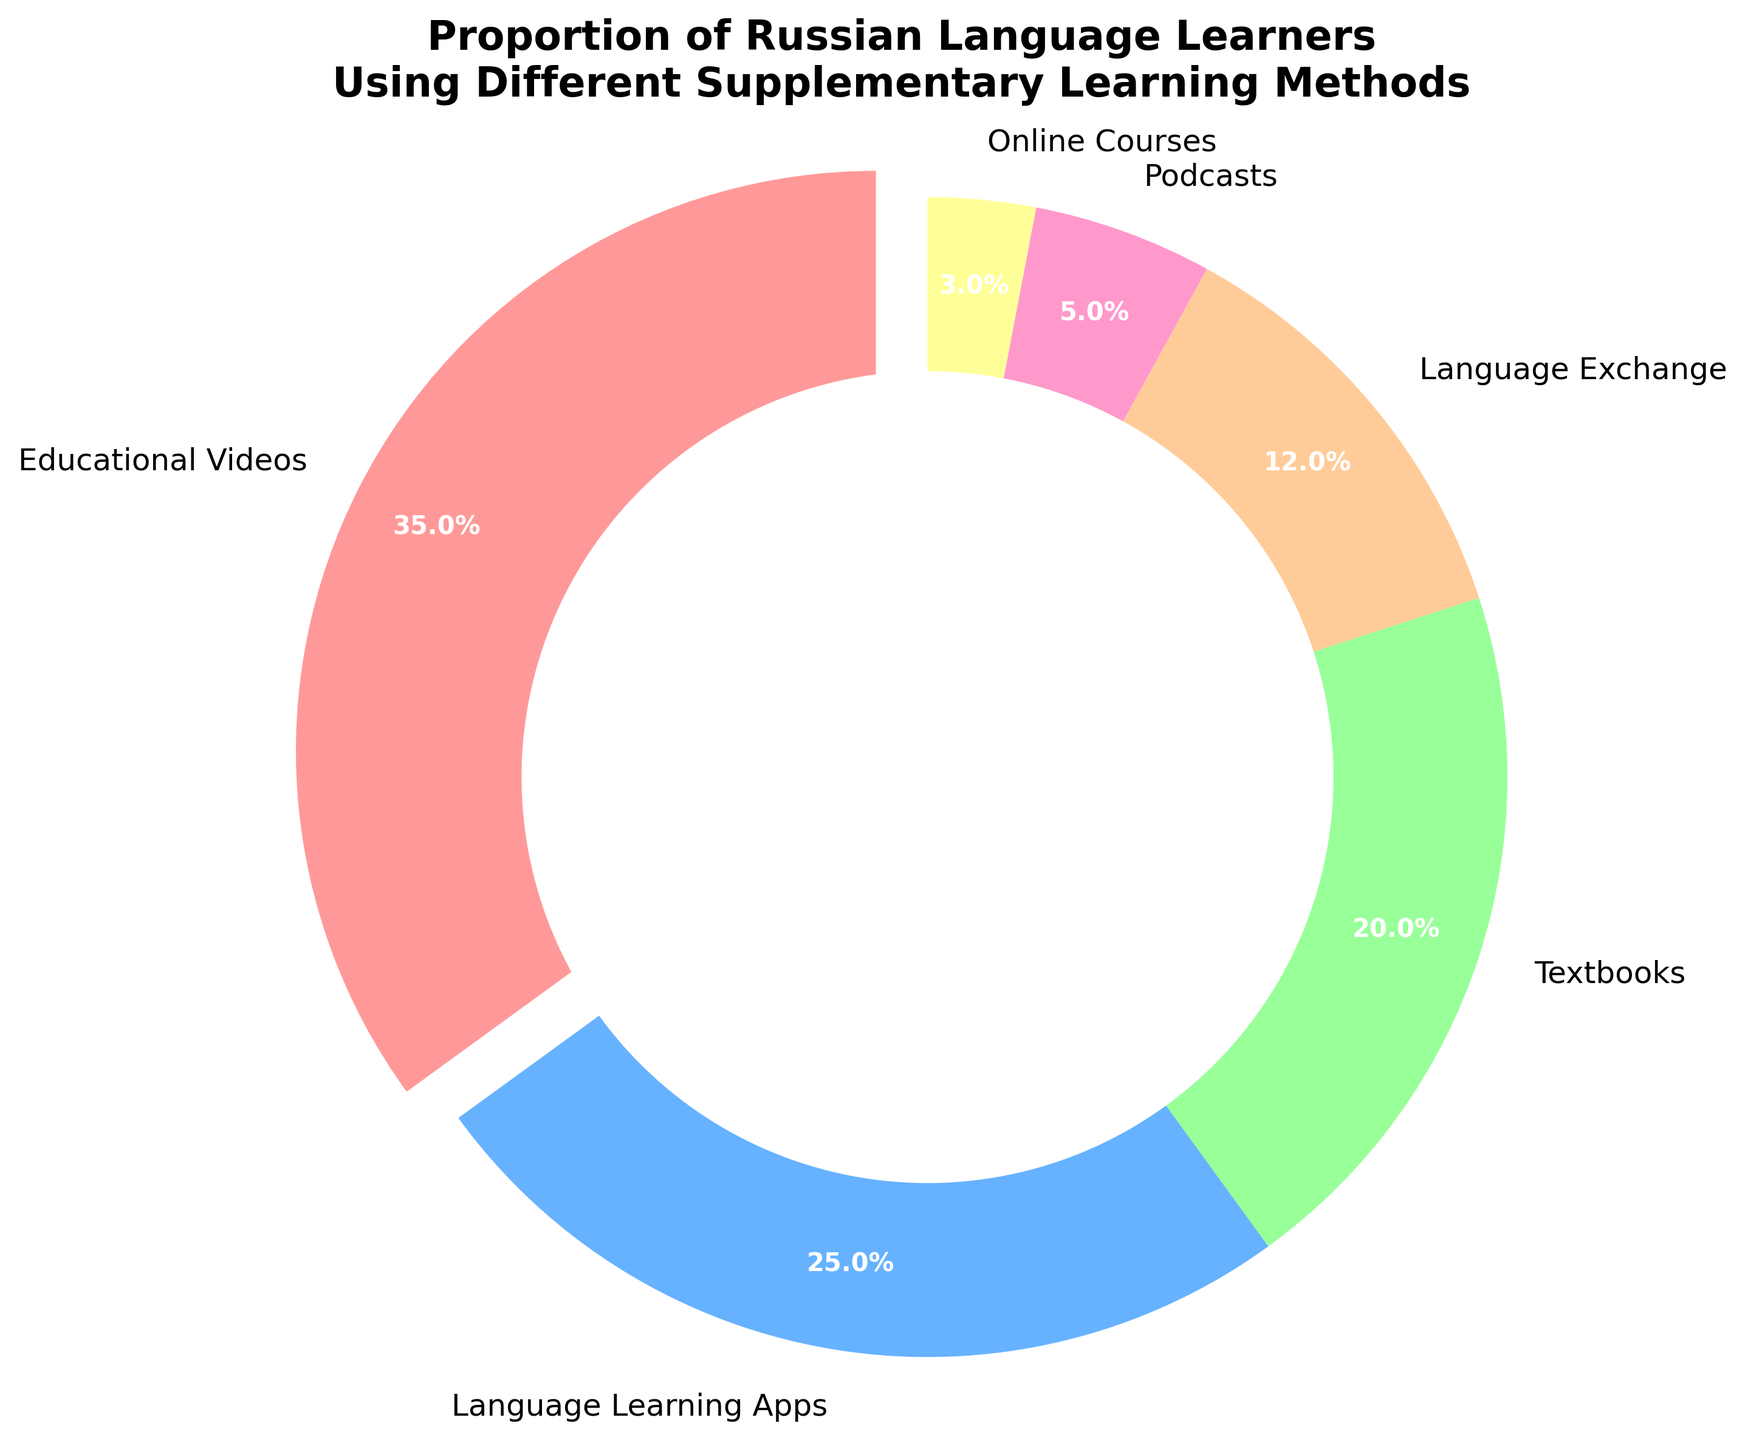what is the percentage of people using educational videos? The pie chart shows that 35% of people use educational videos to study Russian.
Answer: 35% Which method of learning has the second-largest proportion? The pie chart shows the proportions, and the second-largest piece after educational videos (35%) is language learning apps at 25%.
Answer: Language learning apps What is the combined percentage of people using textbooks and language exchange? Textbooks have 20% and language exchange has 12%. Adding these together, 20% + 12% = 32%.
Answer: 32% Which learning method is represented with the lightest color, and what is its percentage? The lightest segment on the chart represents online courses. Its percentage is shown as 3%.
Answer: Online courses, 3% Which method is less popular, podcasts or online courses? By comparing the segments, podcasts are represented by 5% while online courses have 3%. Thus, online courses are less popular.
Answer: Online courses How much more popular are educational videos compared to textbooks? Educational videos have 35% and textbooks have 20%. The difference between 35% and 20% is 35% - 20% = 15%.
Answer: 15% What is the total percentage of all methods used other than educational videos? The total percentage for other methods: 25% (apps) + 20% (textbooks) + 12% (language exchange) + 5% (podcasts) + 3% (online courses) = 65%.
Answer: 65% If 1000 people were surveyed, how many of them use language learning apps? 25% of 1000 people is calculated as 1000 * 0.25 = 250 people.
Answer: 250 What is the difference in percentage between the least and the most popular methods? The least popular method is online courses at 3%, and the most popular is educational videos at 35%. The difference is 35% - 3% = 32%.
Answer: 32% Which color represents the second smallest segment, and what method does it refer to? The second smallest segment is represented slightly darker than the lightest one, which corresponds to podcasts. Podcasts are 5%.
Answer: Podcasts 